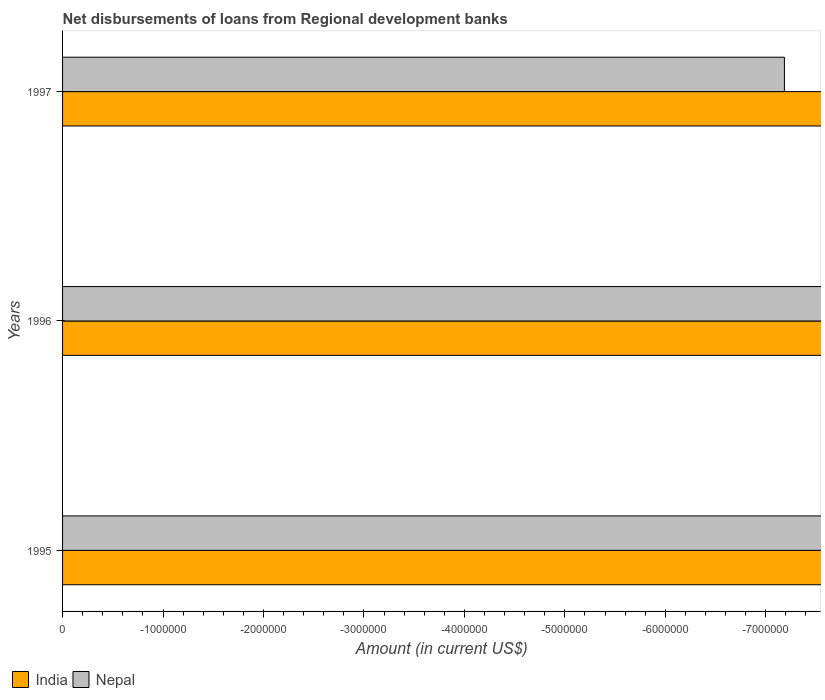How many different coloured bars are there?
Offer a very short reply. 0. Are the number of bars per tick equal to the number of legend labels?
Your answer should be compact. No. How many bars are there on the 3rd tick from the bottom?
Your answer should be compact. 0. In how many cases, is the number of bars for a given year not equal to the number of legend labels?
Offer a very short reply. 3. What is the amount of disbursements of loans from regional development banks in India in 1995?
Provide a short and direct response. 0. Across all years, what is the minimum amount of disbursements of loans from regional development banks in India?
Your answer should be very brief. 0. What is the difference between the amount of disbursements of loans from regional development banks in Nepal in 1997 and the amount of disbursements of loans from regional development banks in India in 1995?
Offer a terse response. 0. In how many years, is the amount of disbursements of loans from regional development banks in India greater than -5400000 US$?
Your response must be concise. 0. In how many years, is the amount of disbursements of loans from regional development banks in Nepal greater than the average amount of disbursements of loans from regional development banks in Nepal taken over all years?
Ensure brevity in your answer.  0. How many bars are there?
Make the answer very short. 0. Are all the bars in the graph horizontal?
Ensure brevity in your answer.  Yes. How many years are there in the graph?
Provide a short and direct response. 3. Does the graph contain grids?
Your answer should be compact. No. Where does the legend appear in the graph?
Ensure brevity in your answer.  Bottom left. How many legend labels are there?
Your answer should be very brief. 2. What is the title of the graph?
Provide a succinct answer. Net disbursements of loans from Regional development banks. Does "Moldova" appear as one of the legend labels in the graph?
Make the answer very short. No. What is the label or title of the Y-axis?
Make the answer very short. Years. What is the Amount (in current US$) in India in 1995?
Your answer should be compact. 0. What is the Amount (in current US$) in Nepal in 1995?
Offer a terse response. 0. What is the Amount (in current US$) of Nepal in 1996?
Offer a very short reply. 0. What is the Amount (in current US$) of Nepal in 1997?
Make the answer very short. 0. What is the total Amount (in current US$) in India in the graph?
Provide a short and direct response. 0. 